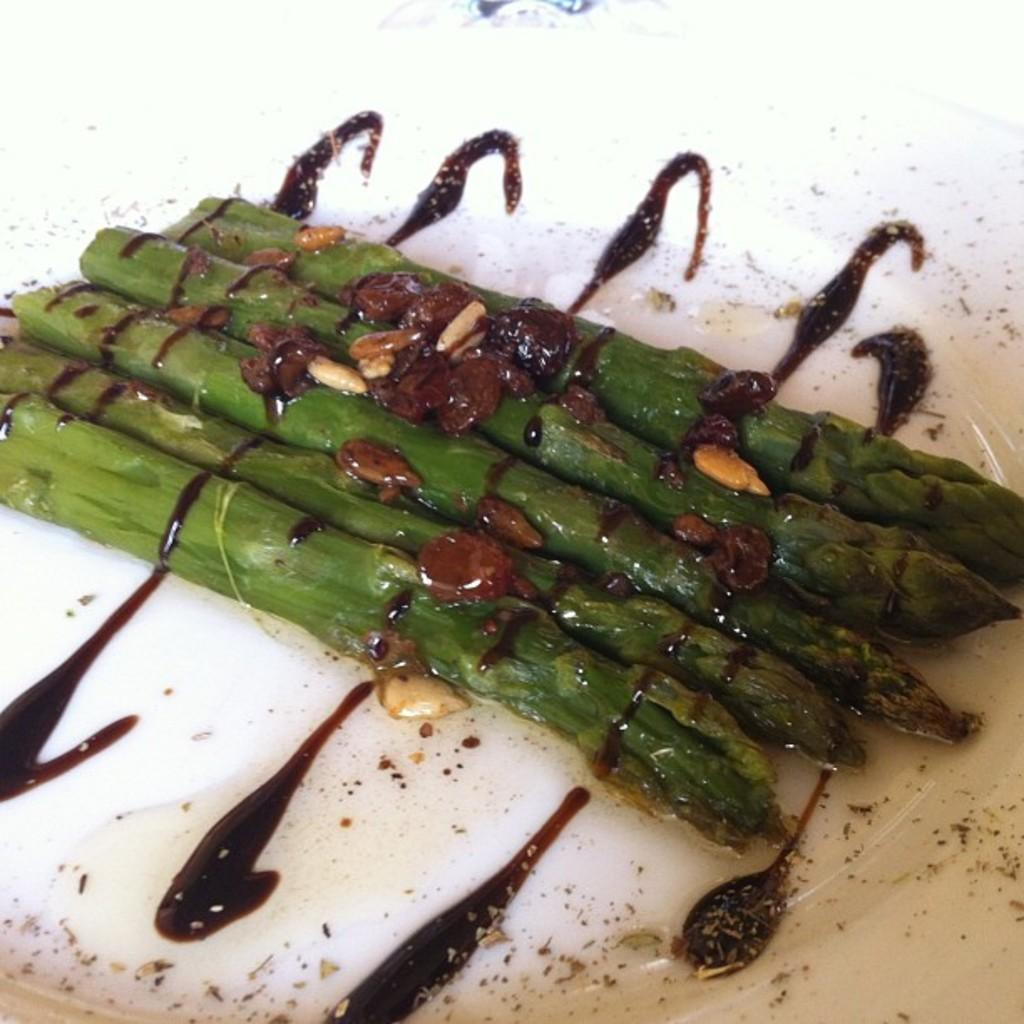What is the main subject of the image? There is a food item in the image. How is the food item presented in the image? The food item is in a white plate. What type of bead is used to decorate the food item in the image? There is no bead present in the image, as it features a food item in a white plate. 